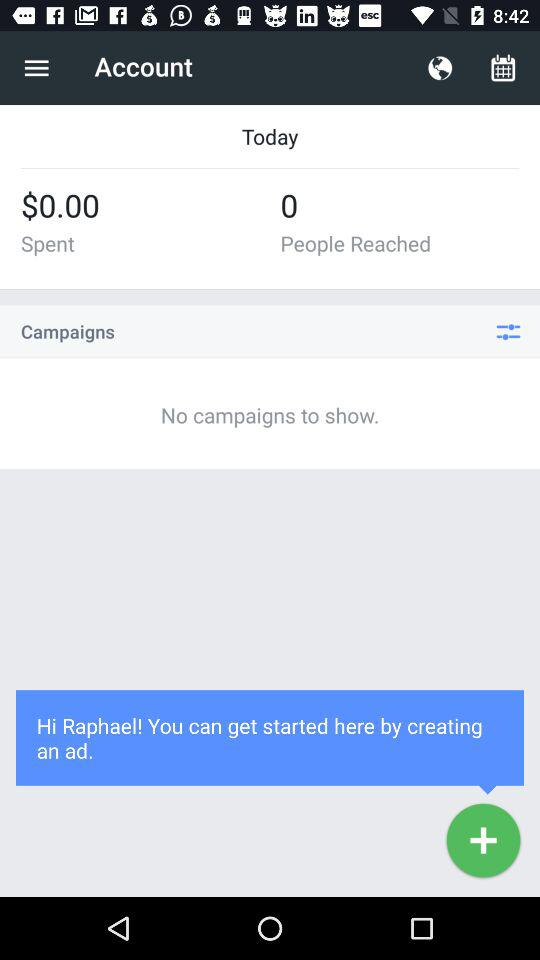Are there any campaigns? There are no campaigns. 